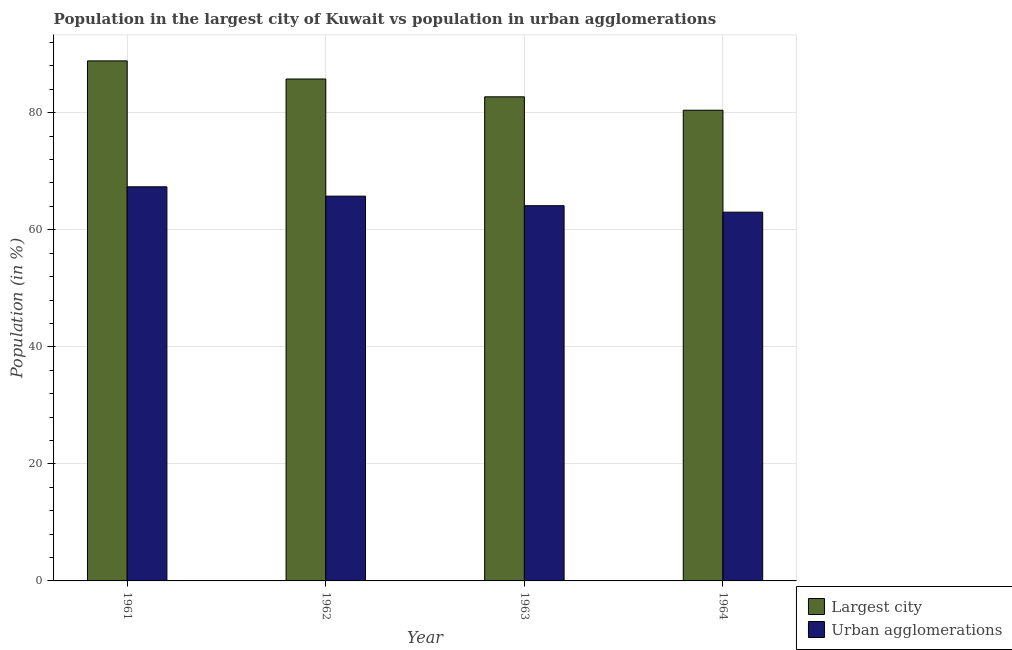How many different coloured bars are there?
Keep it short and to the point. 2. What is the label of the 1st group of bars from the left?
Give a very brief answer. 1961. What is the population in the largest city in 1963?
Give a very brief answer. 82.72. Across all years, what is the maximum population in urban agglomerations?
Provide a succinct answer. 67.34. Across all years, what is the minimum population in the largest city?
Offer a terse response. 80.43. In which year was the population in urban agglomerations minimum?
Offer a very short reply. 1964. What is the total population in the largest city in the graph?
Give a very brief answer. 337.77. What is the difference between the population in the largest city in 1961 and that in 1962?
Ensure brevity in your answer.  3.1. What is the difference between the population in the largest city in 1963 and the population in urban agglomerations in 1962?
Give a very brief answer. -3.04. What is the average population in urban agglomerations per year?
Ensure brevity in your answer.  65.05. In the year 1962, what is the difference between the population in the largest city and population in urban agglomerations?
Your response must be concise. 0. In how many years, is the population in the largest city greater than 44 %?
Ensure brevity in your answer.  4. What is the ratio of the population in urban agglomerations in 1961 to that in 1964?
Ensure brevity in your answer.  1.07. Is the population in the largest city in 1961 less than that in 1964?
Make the answer very short. No. What is the difference between the highest and the second highest population in urban agglomerations?
Ensure brevity in your answer.  1.6. What is the difference between the highest and the lowest population in urban agglomerations?
Give a very brief answer. 4.34. Is the sum of the population in the largest city in 1962 and 1964 greater than the maximum population in urban agglomerations across all years?
Provide a succinct answer. Yes. What does the 2nd bar from the left in 1963 represents?
Offer a terse response. Urban agglomerations. What does the 2nd bar from the right in 1963 represents?
Make the answer very short. Largest city. How many bars are there?
Give a very brief answer. 8. How many legend labels are there?
Give a very brief answer. 2. How are the legend labels stacked?
Give a very brief answer. Vertical. What is the title of the graph?
Keep it short and to the point. Population in the largest city of Kuwait vs population in urban agglomerations. Does "Research and Development" appear as one of the legend labels in the graph?
Your answer should be very brief. No. What is the label or title of the Y-axis?
Make the answer very short. Population (in %). What is the Population (in %) in Largest city in 1961?
Make the answer very short. 88.86. What is the Population (in %) of Urban agglomerations in 1961?
Keep it short and to the point. 67.34. What is the Population (in %) of Largest city in 1962?
Provide a short and direct response. 85.76. What is the Population (in %) of Urban agglomerations in 1962?
Keep it short and to the point. 65.75. What is the Population (in %) of Largest city in 1963?
Keep it short and to the point. 82.72. What is the Population (in %) in Urban agglomerations in 1963?
Provide a short and direct response. 64.12. What is the Population (in %) of Largest city in 1964?
Offer a very short reply. 80.43. What is the Population (in %) of Urban agglomerations in 1964?
Provide a succinct answer. 63.01. Across all years, what is the maximum Population (in %) in Largest city?
Provide a short and direct response. 88.86. Across all years, what is the maximum Population (in %) in Urban agglomerations?
Offer a very short reply. 67.34. Across all years, what is the minimum Population (in %) of Largest city?
Provide a short and direct response. 80.43. Across all years, what is the minimum Population (in %) in Urban agglomerations?
Make the answer very short. 63.01. What is the total Population (in %) in Largest city in the graph?
Give a very brief answer. 337.77. What is the total Population (in %) of Urban agglomerations in the graph?
Ensure brevity in your answer.  260.21. What is the difference between the Population (in %) of Largest city in 1961 and that in 1962?
Make the answer very short. 3.1. What is the difference between the Population (in %) in Urban agglomerations in 1961 and that in 1962?
Offer a terse response. 1.6. What is the difference between the Population (in %) of Largest city in 1961 and that in 1963?
Your answer should be compact. 6.14. What is the difference between the Population (in %) of Urban agglomerations in 1961 and that in 1963?
Your response must be concise. 3.23. What is the difference between the Population (in %) in Largest city in 1961 and that in 1964?
Keep it short and to the point. 8.43. What is the difference between the Population (in %) of Urban agglomerations in 1961 and that in 1964?
Offer a very short reply. 4.34. What is the difference between the Population (in %) in Largest city in 1962 and that in 1963?
Ensure brevity in your answer.  3.04. What is the difference between the Population (in %) of Urban agglomerations in 1962 and that in 1963?
Ensure brevity in your answer.  1.63. What is the difference between the Population (in %) of Largest city in 1962 and that in 1964?
Provide a short and direct response. 5.33. What is the difference between the Population (in %) of Urban agglomerations in 1962 and that in 1964?
Your response must be concise. 2.74. What is the difference between the Population (in %) in Largest city in 1963 and that in 1964?
Provide a succinct answer. 2.29. What is the difference between the Population (in %) in Urban agglomerations in 1963 and that in 1964?
Keep it short and to the point. 1.11. What is the difference between the Population (in %) of Largest city in 1961 and the Population (in %) of Urban agglomerations in 1962?
Your response must be concise. 23.11. What is the difference between the Population (in %) in Largest city in 1961 and the Population (in %) in Urban agglomerations in 1963?
Offer a very short reply. 24.74. What is the difference between the Population (in %) of Largest city in 1961 and the Population (in %) of Urban agglomerations in 1964?
Make the answer very short. 25.85. What is the difference between the Population (in %) of Largest city in 1962 and the Population (in %) of Urban agglomerations in 1963?
Provide a short and direct response. 21.65. What is the difference between the Population (in %) of Largest city in 1962 and the Population (in %) of Urban agglomerations in 1964?
Give a very brief answer. 22.75. What is the difference between the Population (in %) in Largest city in 1963 and the Population (in %) in Urban agglomerations in 1964?
Ensure brevity in your answer.  19.71. What is the average Population (in %) in Largest city per year?
Keep it short and to the point. 84.44. What is the average Population (in %) of Urban agglomerations per year?
Offer a terse response. 65.05. In the year 1961, what is the difference between the Population (in %) in Largest city and Population (in %) in Urban agglomerations?
Provide a short and direct response. 21.52. In the year 1962, what is the difference between the Population (in %) of Largest city and Population (in %) of Urban agglomerations?
Your answer should be very brief. 20.02. In the year 1963, what is the difference between the Population (in %) in Largest city and Population (in %) in Urban agglomerations?
Offer a very short reply. 18.6. In the year 1964, what is the difference between the Population (in %) in Largest city and Population (in %) in Urban agglomerations?
Keep it short and to the point. 17.42. What is the ratio of the Population (in %) of Largest city in 1961 to that in 1962?
Keep it short and to the point. 1.04. What is the ratio of the Population (in %) in Urban agglomerations in 1961 to that in 1962?
Give a very brief answer. 1.02. What is the ratio of the Population (in %) in Largest city in 1961 to that in 1963?
Make the answer very short. 1.07. What is the ratio of the Population (in %) of Urban agglomerations in 1961 to that in 1963?
Keep it short and to the point. 1.05. What is the ratio of the Population (in %) of Largest city in 1961 to that in 1964?
Offer a terse response. 1.1. What is the ratio of the Population (in %) of Urban agglomerations in 1961 to that in 1964?
Provide a short and direct response. 1.07. What is the ratio of the Population (in %) of Largest city in 1962 to that in 1963?
Provide a succinct answer. 1.04. What is the ratio of the Population (in %) in Urban agglomerations in 1962 to that in 1963?
Offer a terse response. 1.03. What is the ratio of the Population (in %) in Largest city in 1962 to that in 1964?
Keep it short and to the point. 1.07. What is the ratio of the Population (in %) in Urban agglomerations in 1962 to that in 1964?
Offer a very short reply. 1.04. What is the ratio of the Population (in %) in Largest city in 1963 to that in 1964?
Make the answer very short. 1.03. What is the ratio of the Population (in %) of Urban agglomerations in 1963 to that in 1964?
Offer a very short reply. 1.02. What is the difference between the highest and the second highest Population (in %) in Largest city?
Make the answer very short. 3.1. What is the difference between the highest and the second highest Population (in %) of Urban agglomerations?
Offer a terse response. 1.6. What is the difference between the highest and the lowest Population (in %) in Largest city?
Your answer should be very brief. 8.43. What is the difference between the highest and the lowest Population (in %) of Urban agglomerations?
Keep it short and to the point. 4.34. 